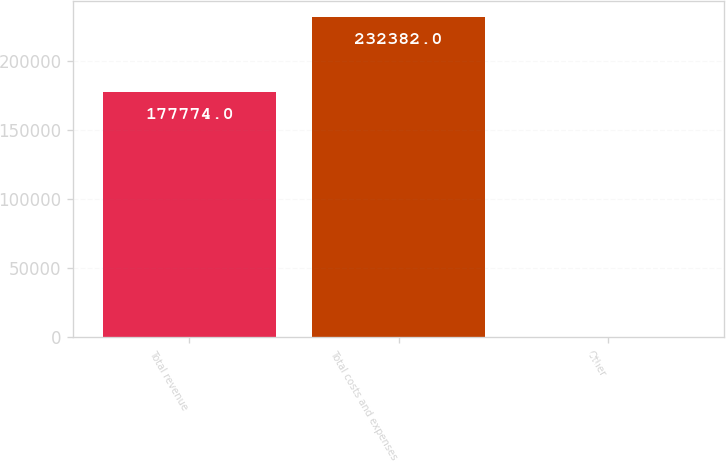Convert chart. <chart><loc_0><loc_0><loc_500><loc_500><bar_chart><fcel>Total revenue<fcel>Total costs and expenses<fcel>Other<nl><fcel>177774<fcel>232382<fcel>23<nl></chart> 